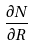Convert formula to latex. <formula><loc_0><loc_0><loc_500><loc_500>\frac { \partial N } { \partial R }</formula> 